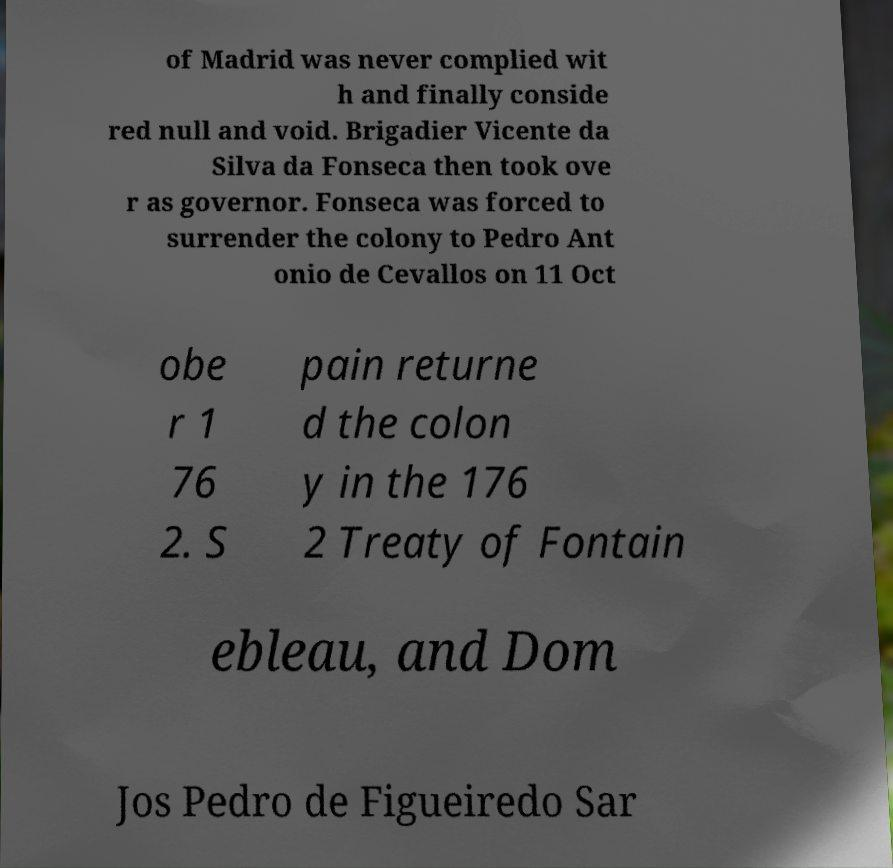Please identify and transcribe the text found in this image. of Madrid was never complied wit h and finally conside red null and void. Brigadier Vicente da Silva da Fonseca then took ove r as governor. Fonseca was forced to surrender the colony to Pedro Ant onio de Cevallos on 11 Oct obe r 1 76 2. S pain returne d the colon y in the 176 2 Treaty of Fontain ebleau, and Dom Jos Pedro de Figueiredo Sar 